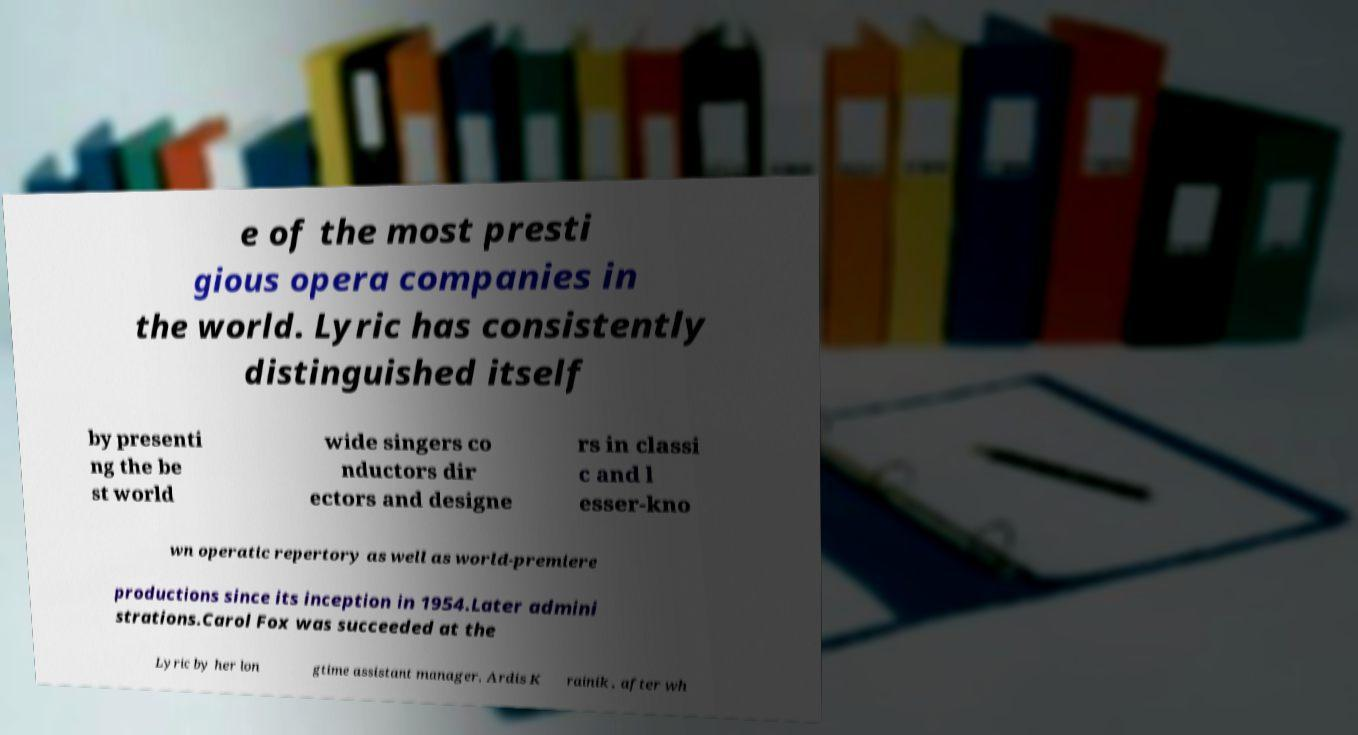For documentation purposes, I need the text within this image transcribed. Could you provide that? e of the most presti gious opera companies in the world. Lyric has consistently distinguished itself by presenti ng the be st world wide singers co nductors dir ectors and designe rs in classi c and l esser-kno wn operatic repertory as well as world-premiere productions since its inception in 1954.Later admini strations.Carol Fox was succeeded at the Lyric by her lon gtime assistant manager, Ardis K rainik , after wh 